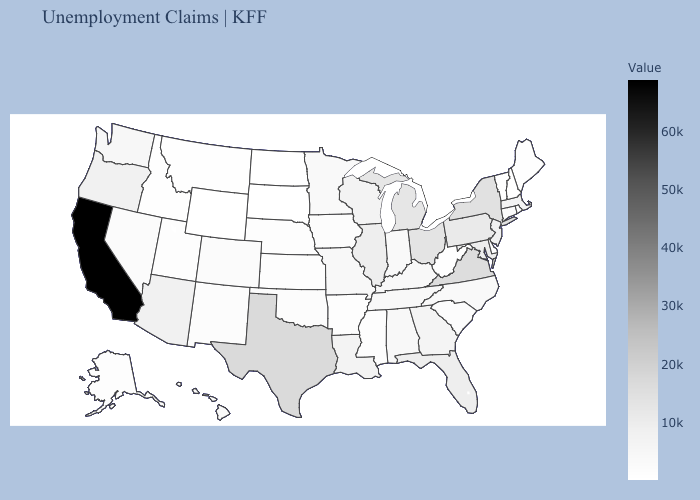Does Alabama have the lowest value in the South?
Answer briefly. No. Which states have the lowest value in the USA?
Keep it brief. South Dakota. Is the legend a continuous bar?
Answer briefly. Yes. Among the states that border Mississippi , does Louisiana have the highest value?
Concise answer only. Yes. Among the states that border North Dakota , which have the highest value?
Be succinct. Minnesota. 